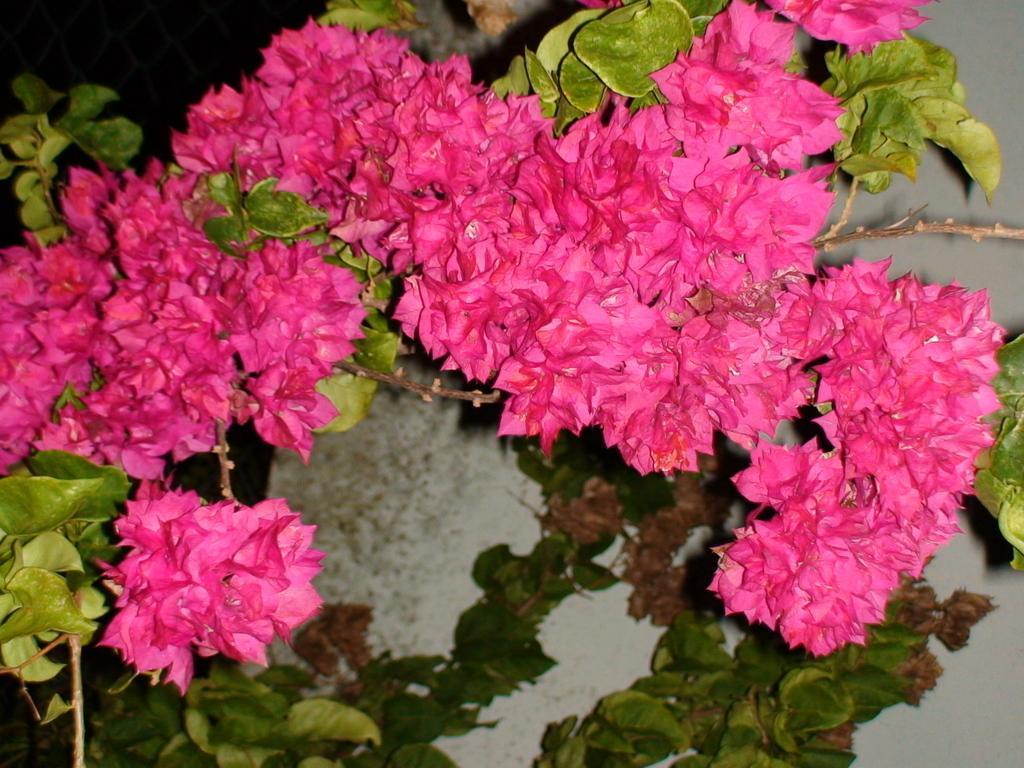Describe this image in one or two sentences. This image is taken outdoors. In this image there is a plant with beautiful flowers. Those flowers are pink in color. 